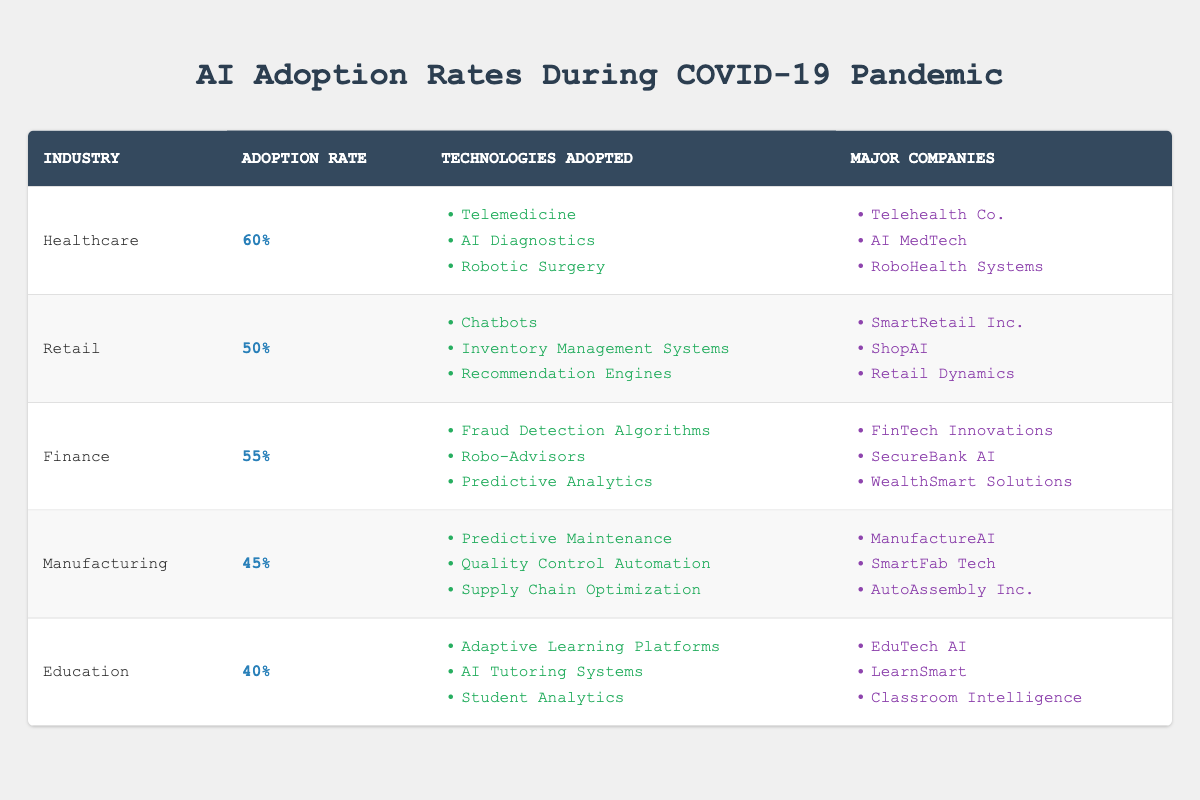What is the adoption rate of AI technologies in Healthcare? The table clearly states that the adoption rate of AI technologies in Healthcare is 60%.
Answer: 60% Which industry has the highest adoption rate of AI technologies during the COVID-19 pandemic? By comparing the adoption rates listed in the table, Healthcare has the highest rate at 60%.
Answer: Healthcare List the major companies in the Finance industry that adopted AI technologies. The table lists the major companies in Finance as FinTech Innovations, SecureBank AI, and WealthSmart Solutions.
Answer: FinTech Innovations, SecureBank AI, WealthSmart Solutions What is the average adoption rate of AI technologies across all listed industries? The adoption rates are 60, 50, 55, 45, and 40. Adding these gives 250. There are 5 industries, so the average is 250 / 5 = 50.
Answer: 50 Is the adoption rate of AI technologies in Education higher than in Manufacturing? The table shows that Education has an adoption rate of 40% and Manufacturing has a rate of 45%, so Education's rate is not higher.
Answer: No What percentage of industries have an adoption rate of 50% or higher? There are three industries (Healthcare, Retail, and Finance) with adoption rates of 50% or higher out of five total industries, resulting in 3/5 = 60%.
Answer: 60% What technology is common in both Healthcare and Finance industries? Looking through the technologies listed under both Healthcare (Telemedicine, AI Diagnostics, Robotic Surgery) and Finance (Fraud Detection Algorithms, Robo-Advisors, Predictive Analytics), there are no common technologies between the two industries based on the data.
Answer: None Calculate the difference in adoption rates between Retail and Education industries. The adoption rate for Retail is 50% and for Education is 40%. The difference is calculated as 50 - 40 = 10%.
Answer: 10% Which industry has the lowest adoption rate of AI technologies? Upon examining the table, it can be seen that Education has the lowest adoption rate at 40%.
Answer: Education 